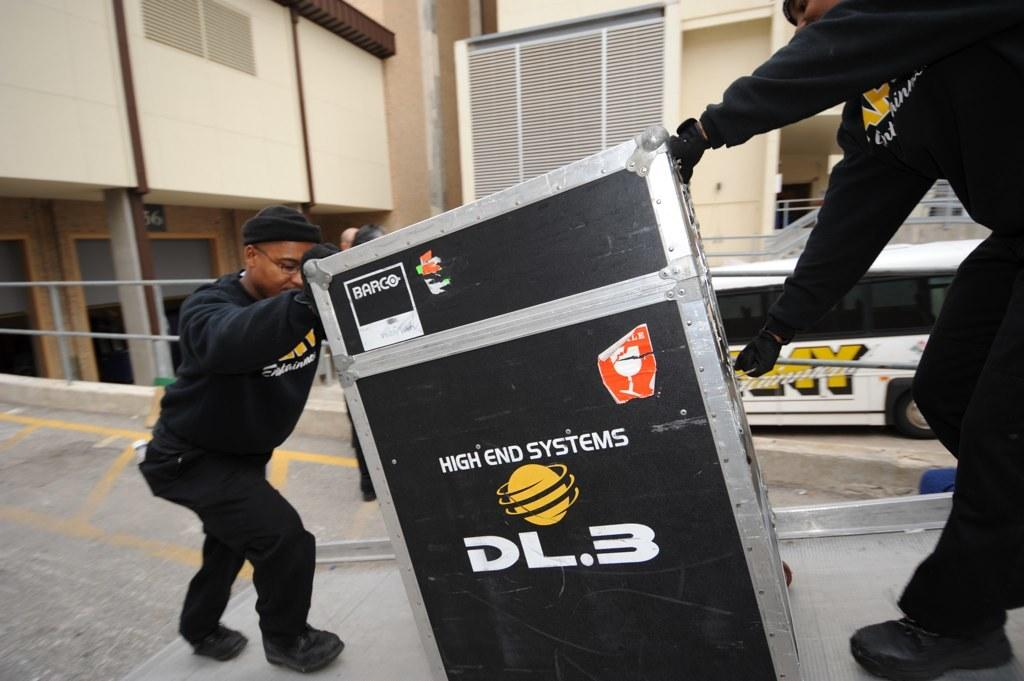What type of structures can be seen in the image? There are buildings in the image. What mode of transportation is present in the image? There is a bus in the image. What are the men in the image doing? The men are holding a box in the image. What color are the men's clothes? The men are wearing black color dress. What headgear are the men wearing? The men are wearing caps on their heads. Reasoning: Let' Let's think step by step in order to produce the conversation. We start by identifying the main subjects and objects in the image based on the provided facts. We then formulate questions that focus on the location and characteristics of these subjects and objects, ensuring that each question can be answered definitively with the information given. We avoid yes/no questions and ensure that the language is simple and clear. Absurd Question/Answer: What type of knowledge can be seen in the image? There is no knowledge present in the image; it contains buildings, a bus, and men holding a box. Can you tell me how many lamps are visible in the image? There are no lamps present in the image. How many lamps are visible in the image? There are no lamps present in the image. 